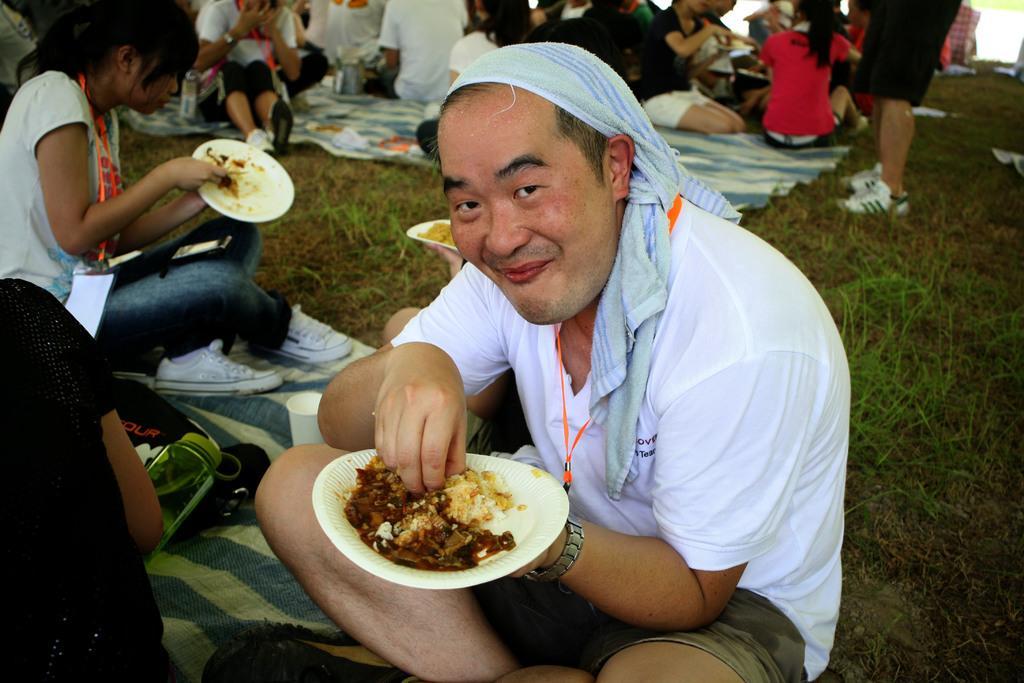How would you summarize this image in a sentence or two? There are two persons wearing white dress is sitting and holding a white color plate which has few eatables placed on it and there are few other persons sitting behind them and the ground is greenery. 